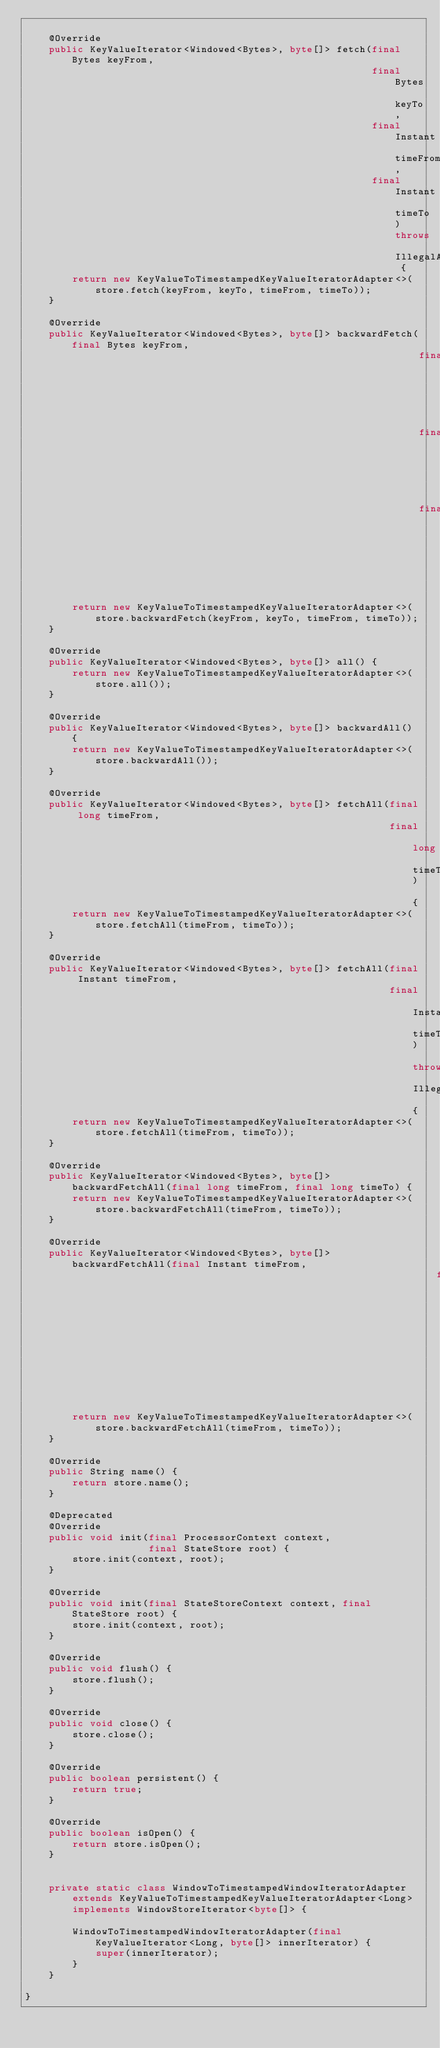Convert code to text. <code><loc_0><loc_0><loc_500><loc_500><_Java_>
    @Override
    public KeyValueIterator<Windowed<Bytes>, byte[]> fetch(final Bytes keyFrom,
                                                           final Bytes keyTo,
                                                           final Instant timeFrom,
                                                           final Instant timeTo)  throws IllegalArgumentException {
        return new KeyValueToTimestampedKeyValueIteratorAdapter<>(store.fetch(keyFrom, keyTo, timeFrom, timeTo));
    }

    @Override
    public KeyValueIterator<Windowed<Bytes>, byte[]> backwardFetch(final Bytes keyFrom,
                                                                   final Bytes keyTo,
                                                                   final long timeFrom,
                                                                   final long timeTo) {
        return new KeyValueToTimestampedKeyValueIteratorAdapter<>(store.backwardFetch(keyFrom, keyTo, timeFrom, timeTo));
    }

    @Override
    public KeyValueIterator<Windowed<Bytes>, byte[]> all() {
        return new KeyValueToTimestampedKeyValueIteratorAdapter<>(store.all());
    }

    @Override
    public KeyValueIterator<Windowed<Bytes>, byte[]> backwardAll() {
        return new KeyValueToTimestampedKeyValueIteratorAdapter<>(store.backwardAll());
    }

    @Override
    public KeyValueIterator<Windowed<Bytes>, byte[]> fetchAll(final long timeFrom,
                                                              final long timeTo) {
        return new KeyValueToTimestampedKeyValueIteratorAdapter<>(store.fetchAll(timeFrom, timeTo));
    }

    @Override
    public KeyValueIterator<Windowed<Bytes>, byte[]> fetchAll(final Instant timeFrom,
                                                              final Instant timeTo) throws IllegalArgumentException {
        return new KeyValueToTimestampedKeyValueIteratorAdapter<>(store.fetchAll(timeFrom, timeTo));
    }

    @Override
    public KeyValueIterator<Windowed<Bytes>, byte[]> backwardFetchAll(final long timeFrom, final long timeTo) {
        return new KeyValueToTimestampedKeyValueIteratorAdapter<>(store.backwardFetchAll(timeFrom, timeTo));
    }

    @Override
    public KeyValueIterator<Windowed<Bytes>, byte[]> backwardFetchAll(final Instant timeFrom,
                                                                      final Instant timeTo) throws IllegalArgumentException {
        return new KeyValueToTimestampedKeyValueIteratorAdapter<>(store.backwardFetchAll(timeFrom, timeTo));
    }

    @Override
    public String name() {
        return store.name();
    }

    @Deprecated
    @Override
    public void init(final ProcessorContext context,
                     final StateStore root) {
        store.init(context, root);
    }

    @Override
    public void init(final StateStoreContext context, final StateStore root) {
        store.init(context, root);
    }

    @Override
    public void flush() {
        store.flush();
    }

    @Override
    public void close() {
        store.close();
    }

    @Override
    public boolean persistent() {
        return true;
    }

    @Override
    public boolean isOpen() {
        return store.isOpen();
    }


    private static class WindowToTimestampedWindowIteratorAdapter
        extends KeyValueToTimestampedKeyValueIteratorAdapter<Long>
        implements WindowStoreIterator<byte[]> {

        WindowToTimestampedWindowIteratorAdapter(final KeyValueIterator<Long, byte[]> innerIterator) {
            super(innerIterator);
        }
    }

}</code> 